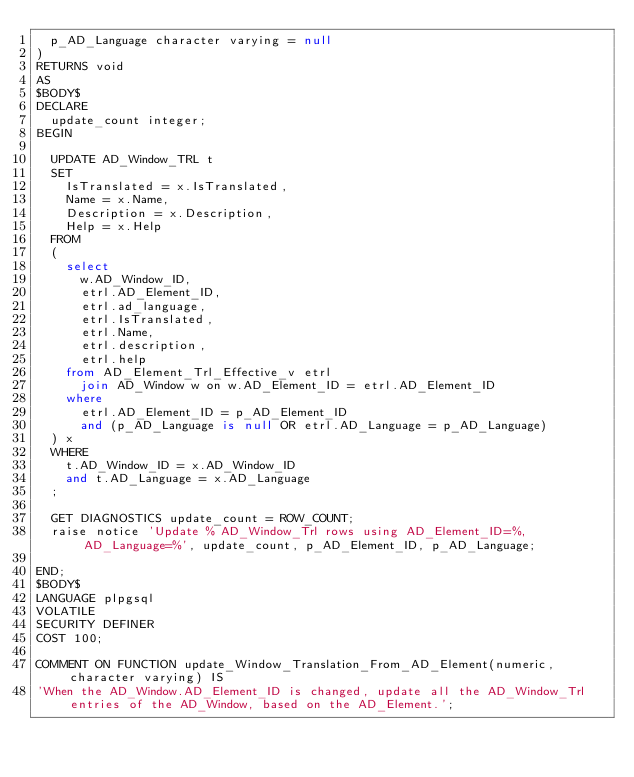Convert code to text. <code><loc_0><loc_0><loc_500><loc_500><_SQL_>	p_AD_Language character varying = null
)
RETURNS void
AS
$BODY$
DECLARE
	update_count integer;
BEGIN
	
	UPDATE AD_Window_TRL t
	SET
		IsTranslated = x.IsTranslated,
		Name = x.Name,
		Description = x.Description,
		Help = x.Help
	FROM
	(
		select
			w.AD_Window_ID,
			etrl.AD_Element_ID,
			etrl.ad_language,
			etrl.IsTranslated,
			etrl.Name,
			etrl.description,
			etrl.help
		from AD_Element_Trl_Effective_v etrl
			join AD_Window w on w.AD_Element_ID = etrl.AD_Element_ID
		where 
			etrl.AD_Element_ID = p_AD_Element_ID  
			and (p_AD_Language is null OR etrl.AD_Language = p_AD_Language)
	) x
	WHERE
		t.AD_Window_ID = x.AD_Window_ID
		and t.AD_Language = x.AD_Language
	;
	
	GET DIAGNOSTICS update_count = ROW_COUNT;
	raise notice 'Update % AD_Window_Trl rows using AD_Element_ID=%, AD_Language=%', update_count, p_AD_Element_ID, p_AD_Language;

END;
$BODY$
LANGUAGE plpgsql
VOLATILE
SECURITY DEFINER
COST 100;

COMMENT ON FUNCTION update_Window_Translation_From_AD_Element(numeric, character varying) IS 
'When the AD_Window.AD_Element_ID is changed, update all the AD_Window_Trl entries of the AD_Window, based on the AD_Element.';
</code> 